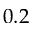<formula> <loc_0><loc_0><loc_500><loc_500>0 . 2</formula> 